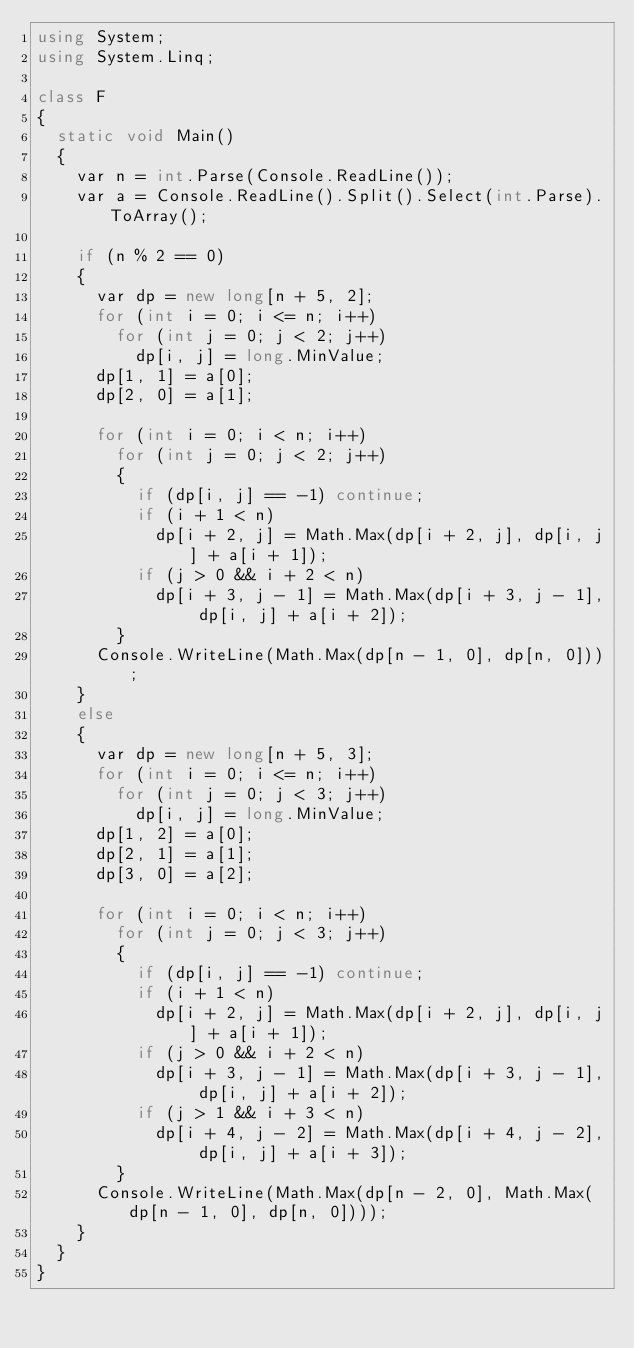<code> <loc_0><loc_0><loc_500><loc_500><_C#_>using System;
using System.Linq;

class F
{
	static void Main()
	{
		var n = int.Parse(Console.ReadLine());
		var a = Console.ReadLine().Split().Select(int.Parse).ToArray();

		if (n % 2 == 0)
		{
			var dp = new long[n + 5, 2];
			for (int i = 0; i <= n; i++)
				for (int j = 0; j < 2; j++)
					dp[i, j] = long.MinValue;
			dp[1, 1] = a[0];
			dp[2, 0] = a[1];

			for (int i = 0; i < n; i++)
				for (int j = 0; j < 2; j++)
				{
					if (dp[i, j] == -1) continue;
					if (i + 1 < n)
						dp[i + 2, j] = Math.Max(dp[i + 2, j], dp[i, j] + a[i + 1]);
					if (j > 0 && i + 2 < n)
						dp[i + 3, j - 1] = Math.Max(dp[i + 3, j - 1], dp[i, j] + a[i + 2]);
				}
			Console.WriteLine(Math.Max(dp[n - 1, 0], dp[n, 0]));
		}
		else
		{
			var dp = new long[n + 5, 3];
			for (int i = 0; i <= n; i++)
				for (int j = 0; j < 3; j++)
					dp[i, j] = long.MinValue;
			dp[1, 2] = a[0];
			dp[2, 1] = a[1];
			dp[3, 0] = a[2];

			for (int i = 0; i < n; i++)
				for (int j = 0; j < 3; j++)
				{
					if (dp[i, j] == -1) continue;
					if (i + 1 < n)
						dp[i + 2, j] = Math.Max(dp[i + 2, j], dp[i, j] + a[i + 1]);
					if (j > 0 && i + 2 < n)
						dp[i + 3, j - 1] = Math.Max(dp[i + 3, j - 1], dp[i, j] + a[i + 2]);
					if (j > 1 && i + 3 < n)
						dp[i + 4, j - 2] = Math.Max(dp[i + 4, j - 2], dp[i, j] + a[i + 3]);
				}
			Console.WriteLine(Math.Max(dp[n - 2, 0], Math.Max(dp[n - 1, 0], dp[n, 0])));
		}
	}
}
</code> 